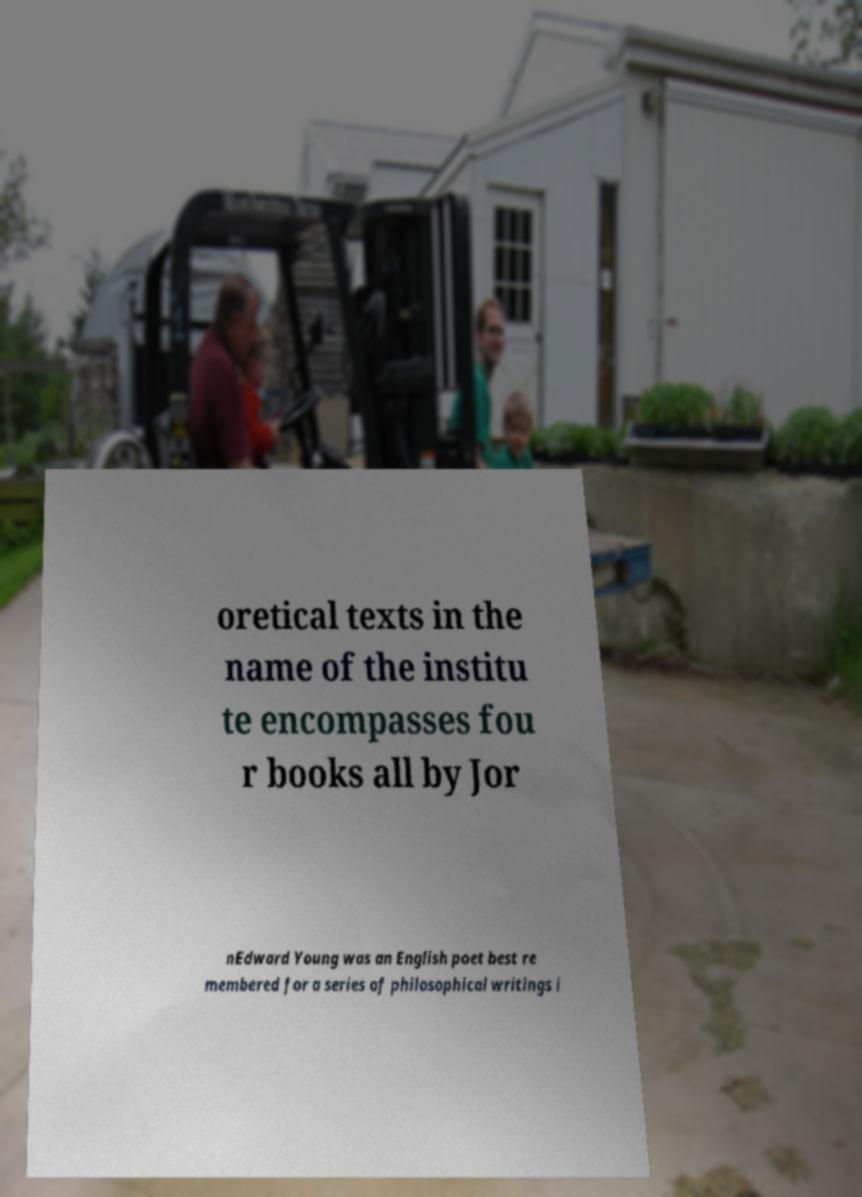There's text embedded in this image that I need extracted. Can you transcribe it verbatim? oretical texts in the name of the institu te encompasses fou r books all by Jor nEdward Young was an English poet best re membered for a series of philosophical writings i 